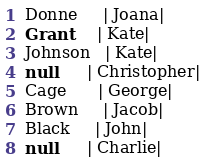<code> <loc_0><loc_0><loc_500><loc_500><_SQL_>Donne     | Joana|
Grant     | Kate|
Johnson   | Kate|
null      | Christopher|
Cage      | George|
Brown     | Jacob|
Black     | John|
null      | Charlie|
</code> 